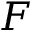Convert formula to latex. <formula><loc_0><loc_0><loc_500><loc_500>F</formula> 